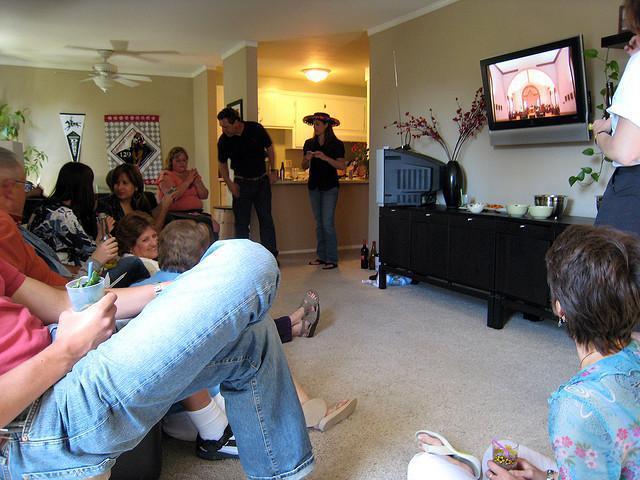How many people are in the photo?
Give a very brief answer. 10. How many tvs are in the photo?
Give a very brief answer. 2. How many round donuts have nuts on them in the image?
Give a very brief answer. 0. 